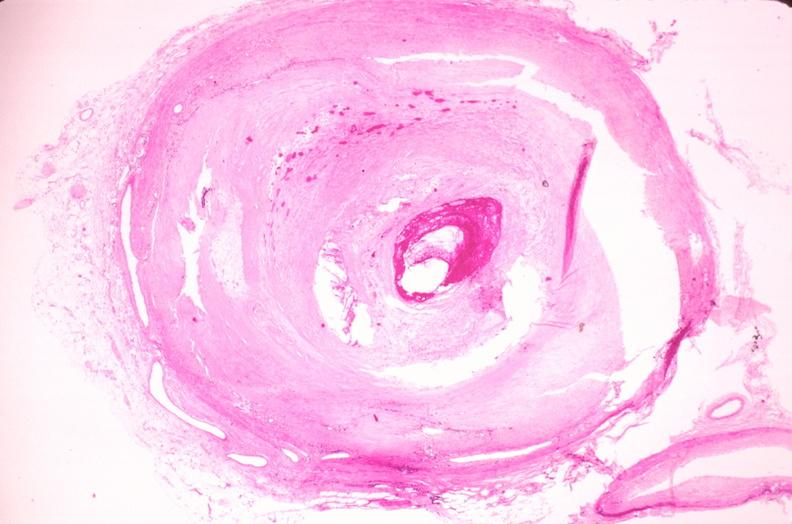what is present?
Answer the question using a single word or phrase. Cardiovascular 